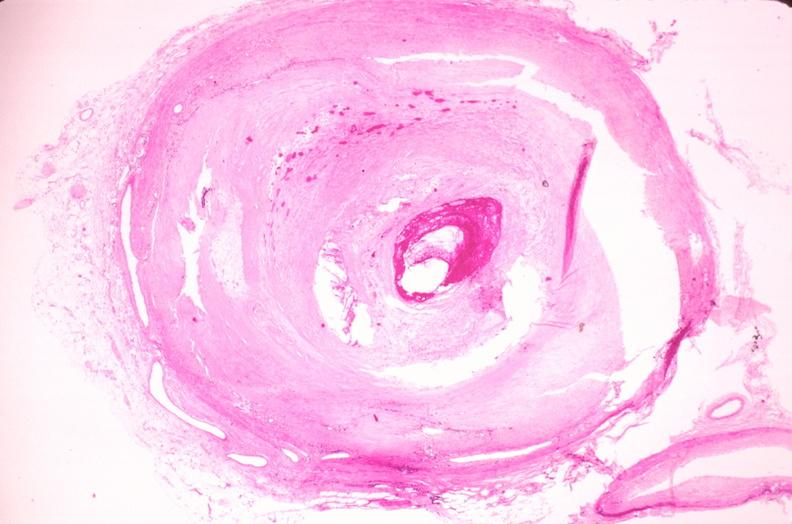what is present?
Answer the question using a single word or phrase. Cardiovascular 